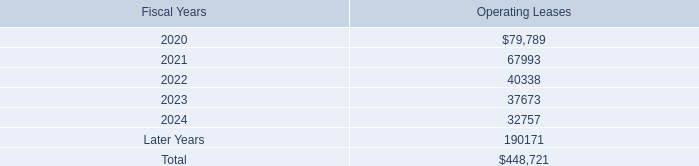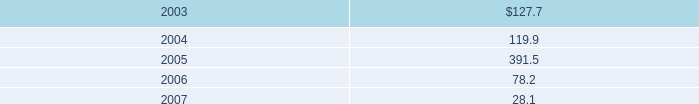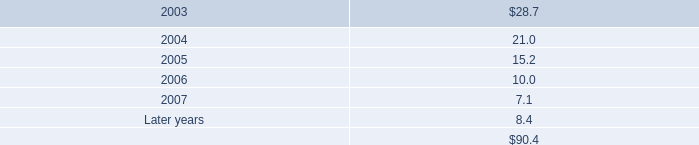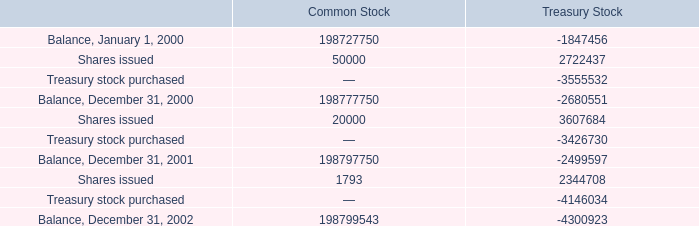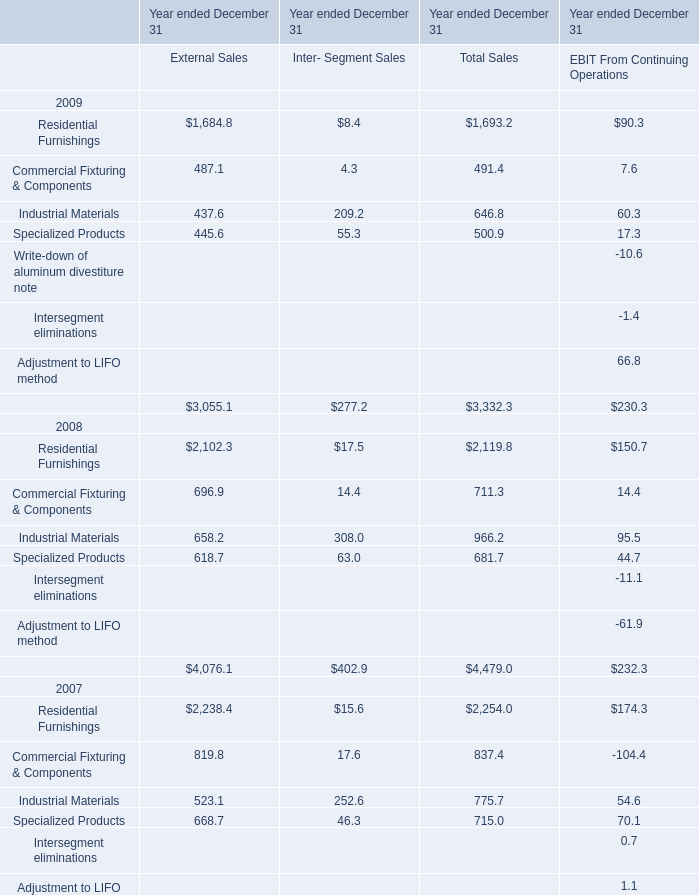What is the sum of Balance, December 31, 2001 of Common Stock, Residential Furnishings of Year ended December 31 External Sales, and Residential Furnishings 2008 of Year ended December 31 Total Sales ? 
Computations: ((198797750.0 + 1684.8) + 2119.8)
Answer: 198801554.6. 